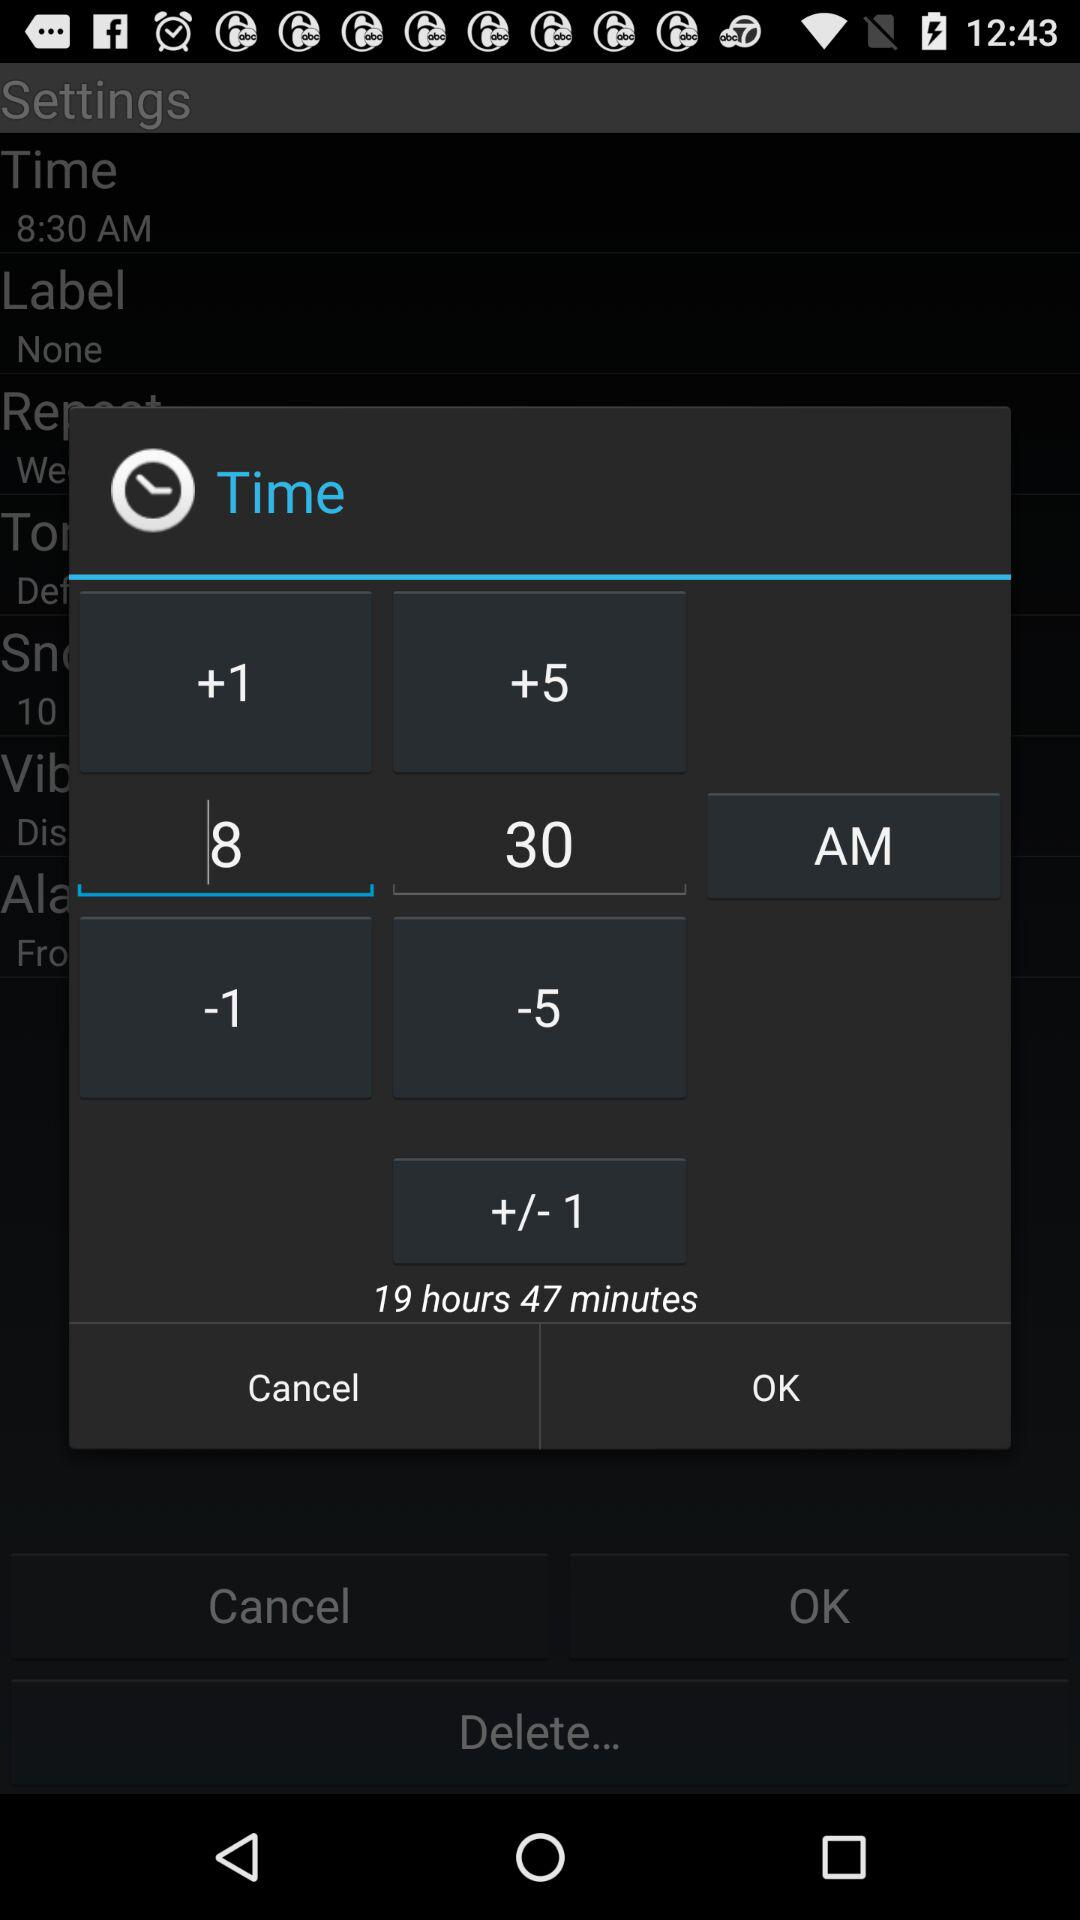What is the frequency of "Snooze"?
When the provided information is insufficient, respond with <no answer>. <no answer> 